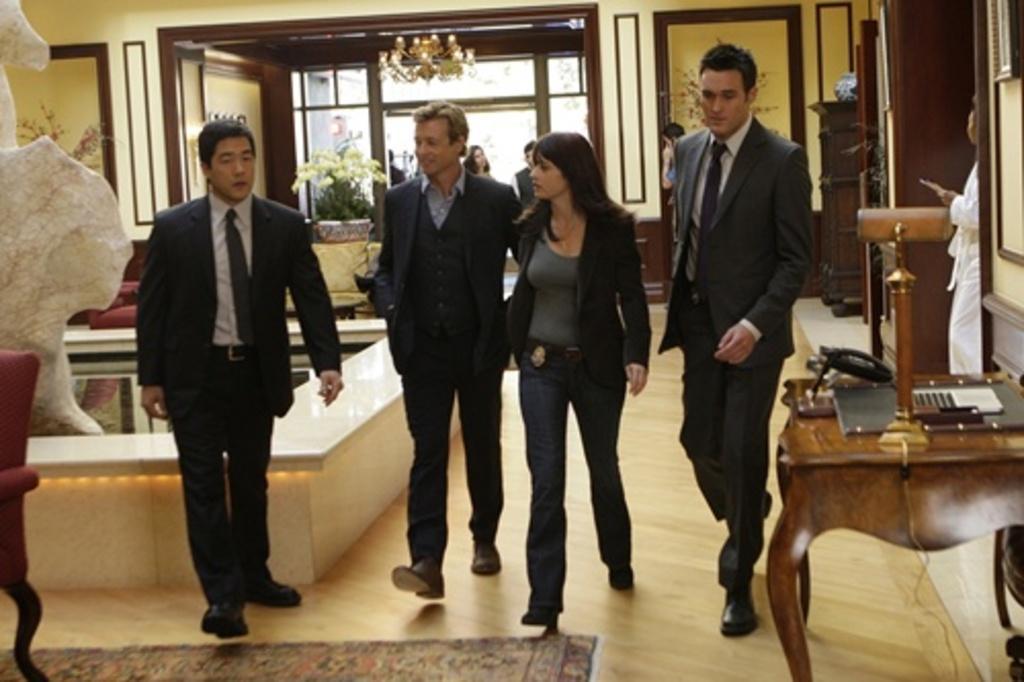Describe this image in one or two sentences. In this picture we can see four persons walking on the floor. This is table and there is a plant. On the background we can see a door. Here these are the frames on the wall. 